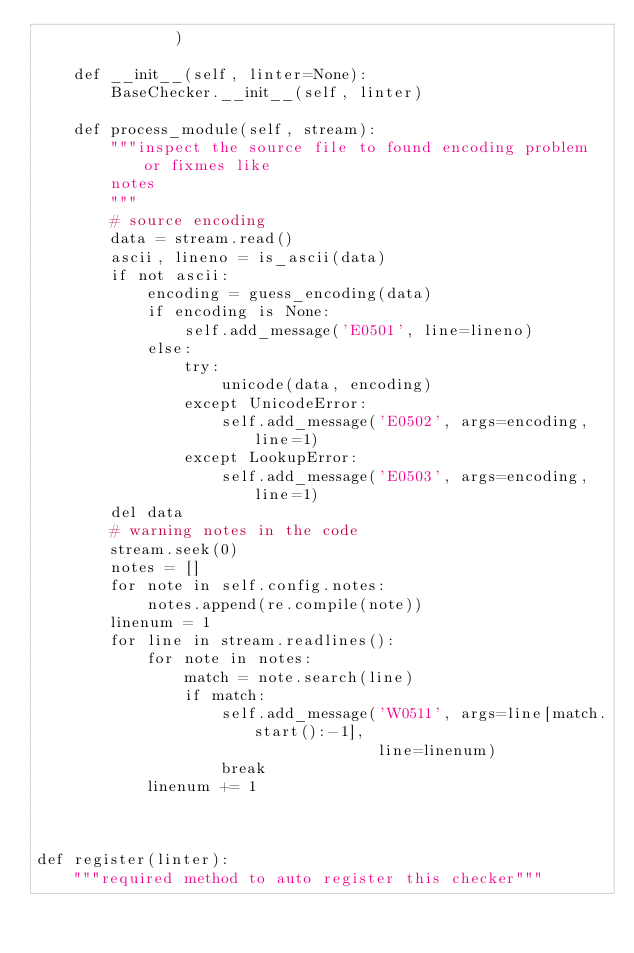<code> <loc_0><loc_0><loc_500><loc_500><_Python_>               )

    def __init__(self, linter=None):
        BaseChecker.__init__(self, linter)
    
    def process_module(self, stream):
        """inspect the source file to found encoding problem or fixmes like
        notes
        """
        # source encoding
        data = stream.read()
        ascii, lineno = is_ascii(data)
        if not ascii:
            encoding = guess_encoding(data)
            if encoding is None:
                self.add_message('E0501', line=lineno)
            else:
                try:
                    unicode(data, encoding)
                except UnicodeError:
                    self.add_message('E0502', args=encoding, line=1)
                except LookupError:
                    self.add_message('E0503', args=encoding, line=1)
        del data
        # warning notes in the code
        stream.seek(0)
        notes = []
        for note in self.config.notes:
            notes.append(re.compile(note))
        linenum = 1
        for line in stream.readlines():
            for note in notes:
                match = note.search(line)
                if match:
                    self.add_message('W0511', args=line[match.start():-1],
                                     line=linenum)
                    break
            linenum += 1
                    
                
            
def register(linter):
    """required method to auto register this checker"""</code> 